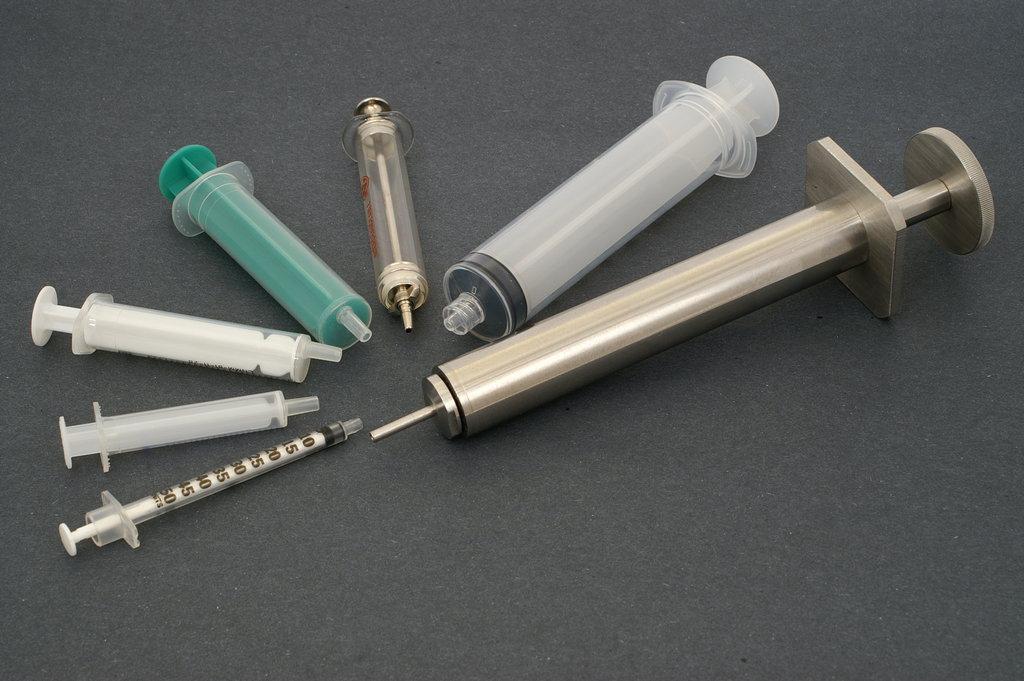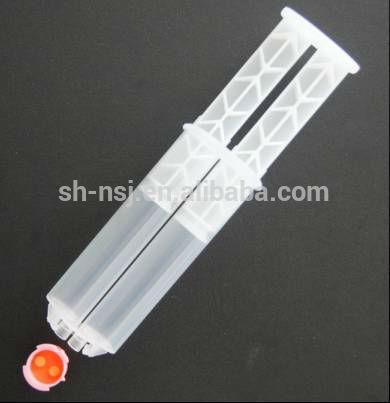The first image is the image on the left, the second image is the image on the right. For the images shown, is this caption "The right image has three syringes." true? Answer yes or no. No. The first image is the image on the left, the second image is the image on the right. Examine the images to the left and right. Is the description "Each image shows exactly three syringe-related items." accurate? Answer yes or no. No. 